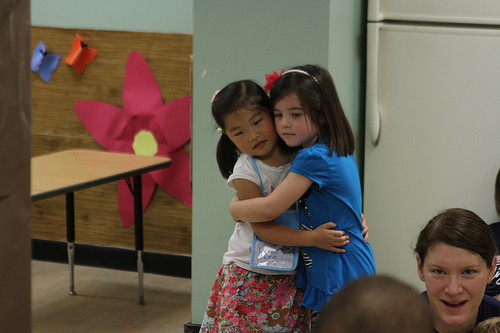<image>
Is the girl on the girl? Yes. Looking at the image, I can see the girl is positioned on top of the girl, with the girl providing support. Is there a girl behind the bag? No. The girl is not behind the bag. From this viewpoint, the girl appears to be positioned elsewhere in the scene. Where is the asian girl in relation to the caucasian girl? Is it in front of the caucasian girl? Yes. The asian girl is positioned in front of the caucasian girl, appearing closer to the camera viewpoint. 